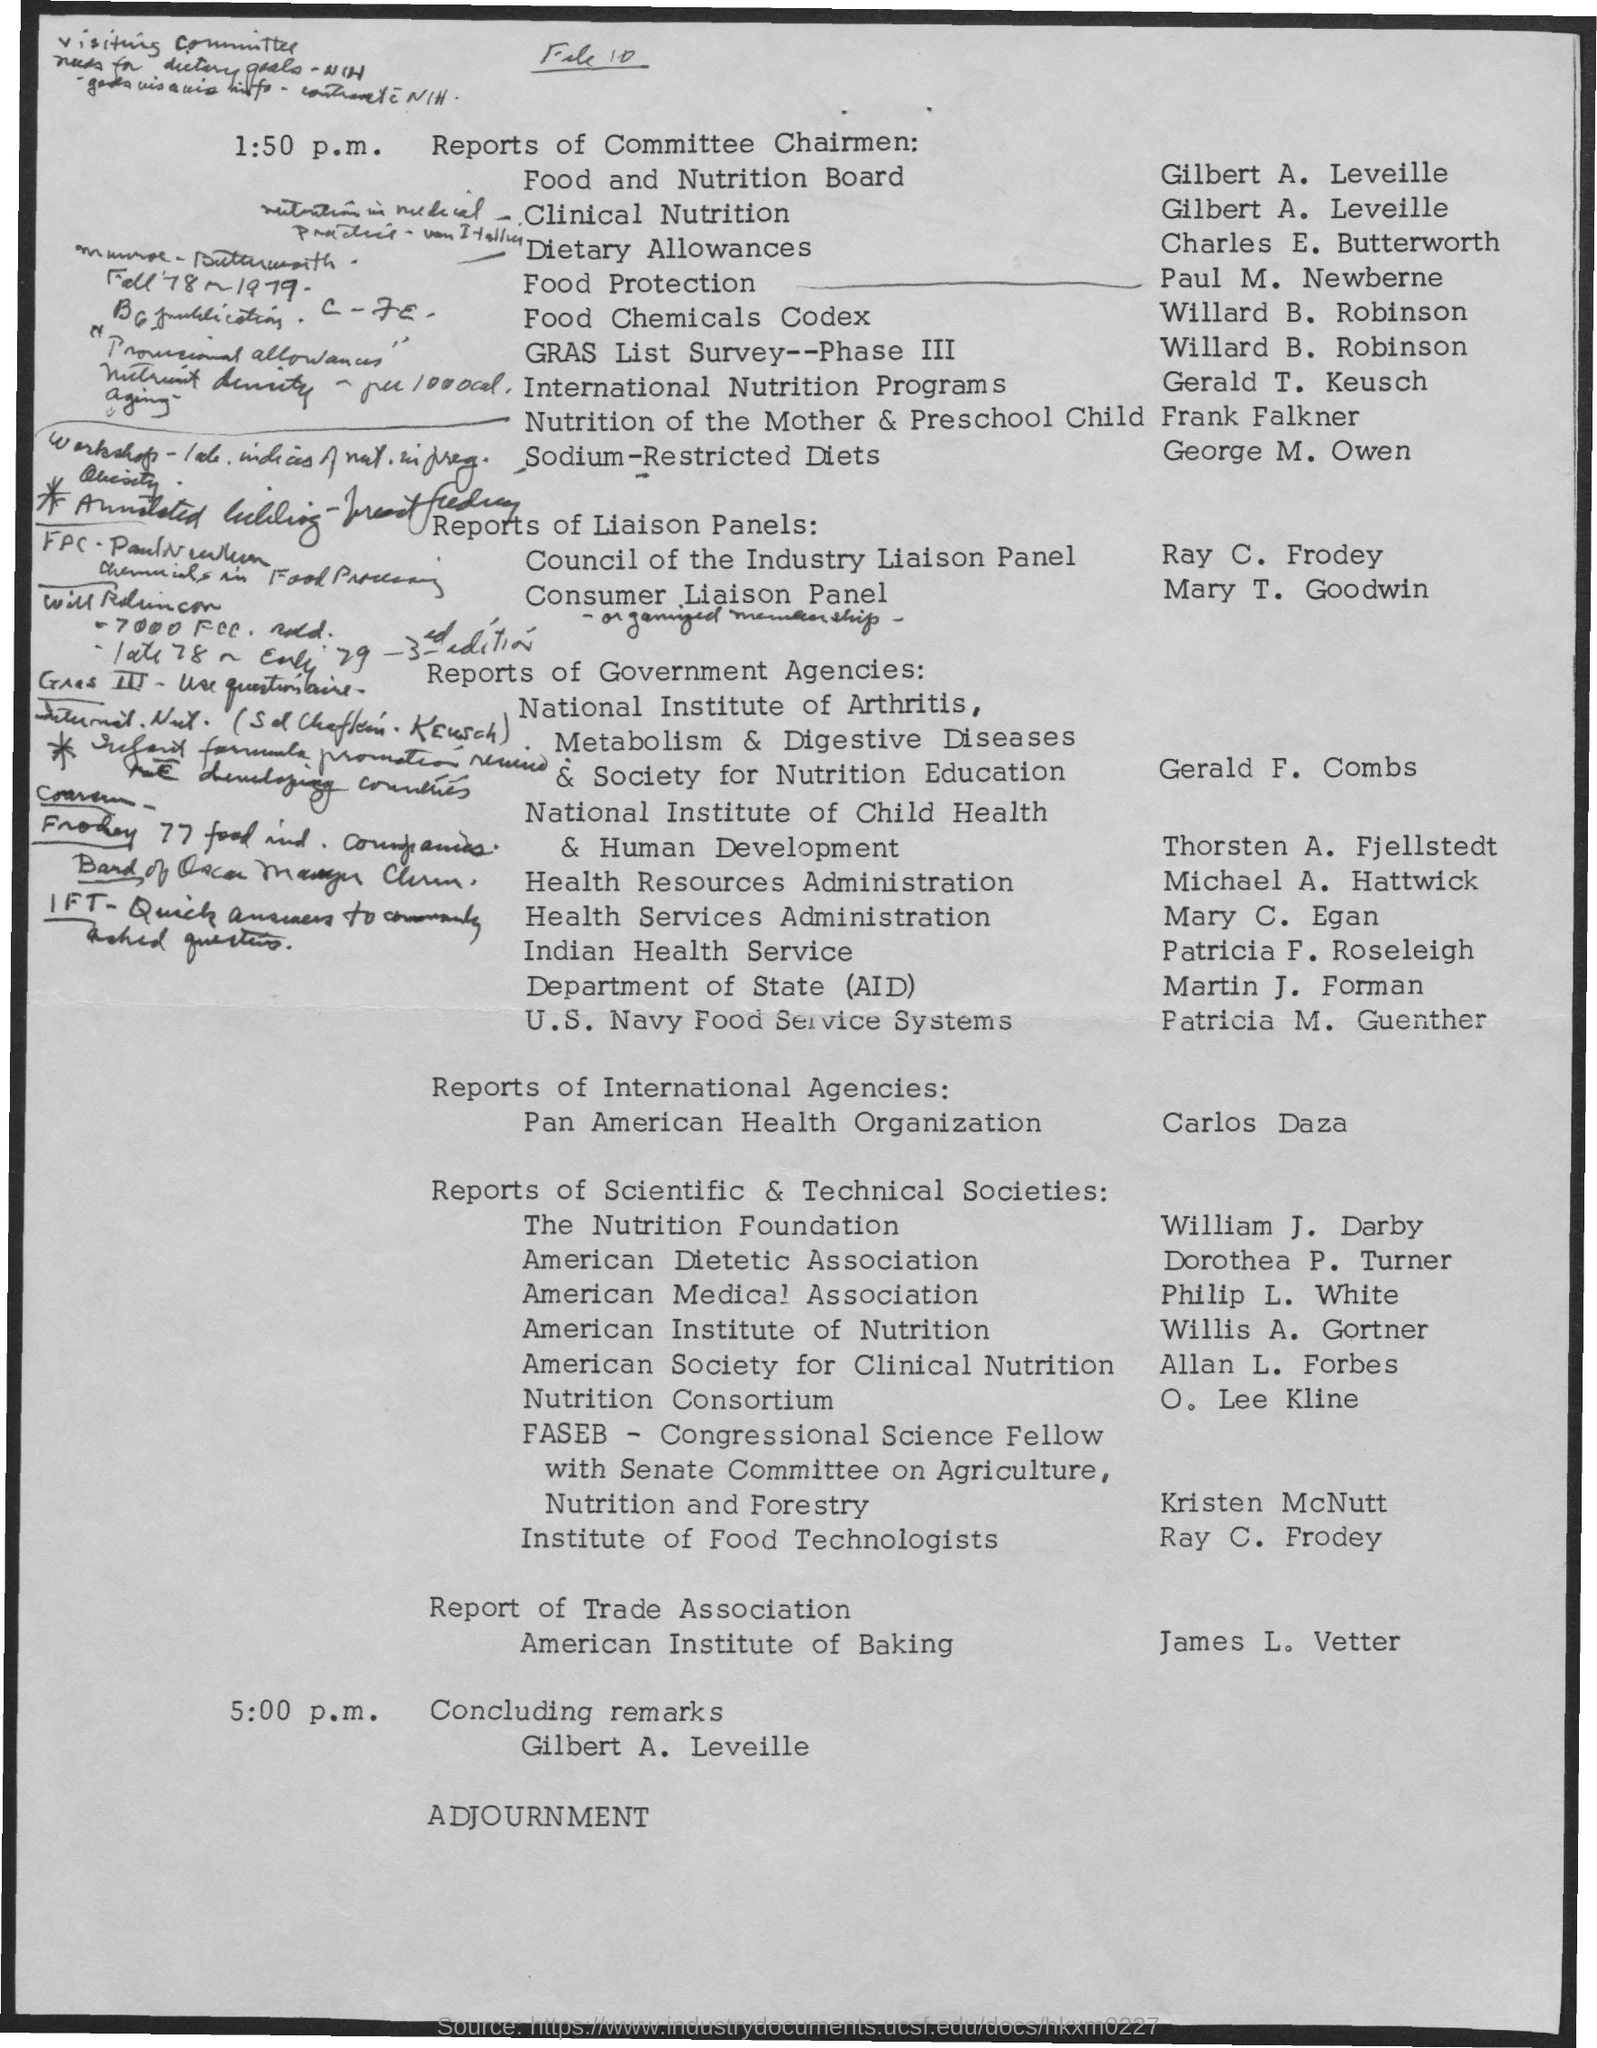Who is the chairman of food and nutrition board?
Make the answer very short. Gilbert A. Leveille. 